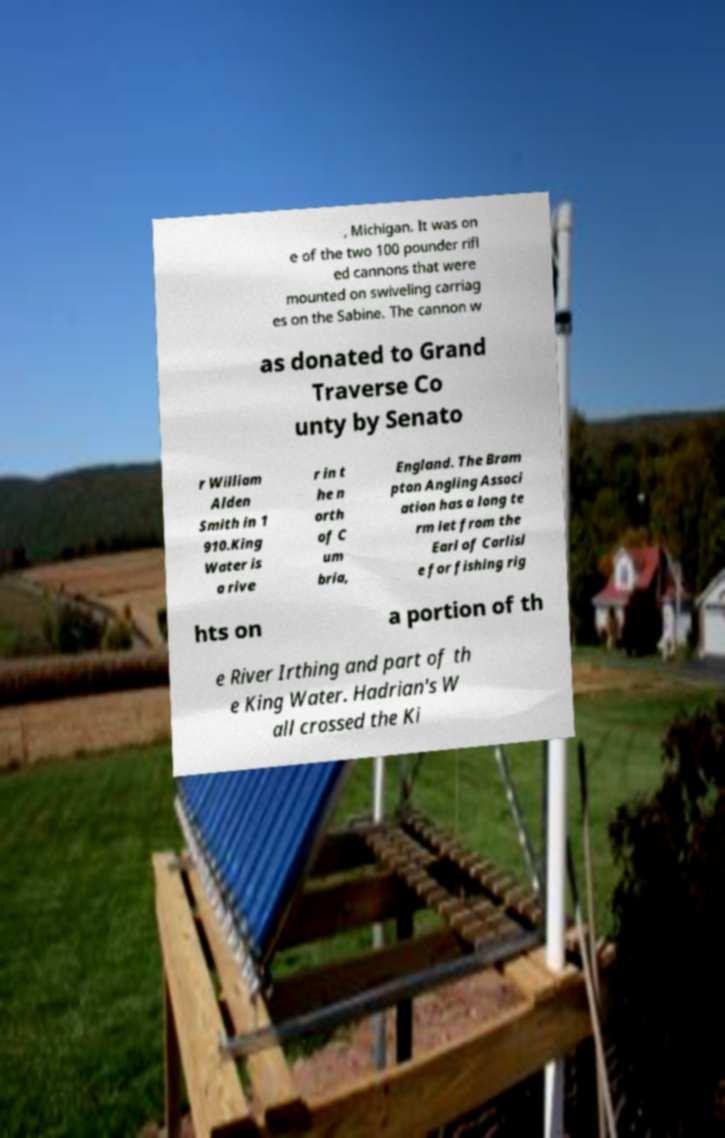For documentation purposes, I need the text within this image transcribed. Could you provide that? , Michigan. It was on e of the two 100 pounder rifl ed cannons that were mounted on swiveling carriag es on the Sabine. The cannon w as donated to Grand Traverse Co unty by Senato r William Alden Smith in 1 910.King Water is a rive r in t he n orth of C um bria, England. The Bram pton Angling Associ ation has a long te rm let from the Earl of Carlisl e for fishing rig hts on a portion of th e River Irthing and part of th e King Water. Hadrian's W all crossed the Ki 